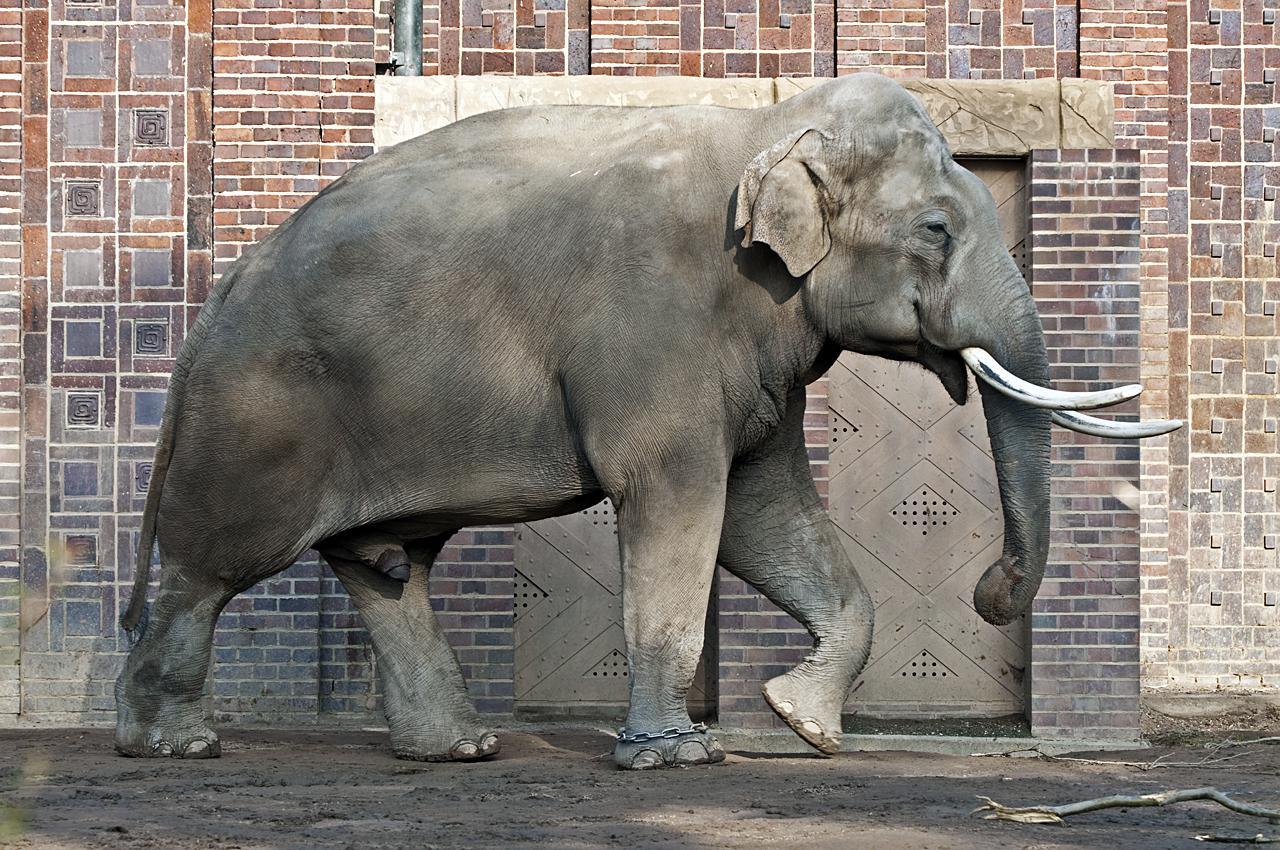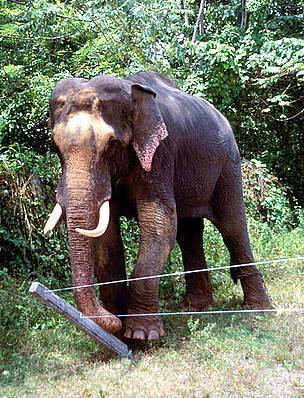The first image is the image on the left, the second image is the image on the right. For the images displayed, is the sentence "There are two elephants in total." factually correct? Answer yes or no. Yes. 